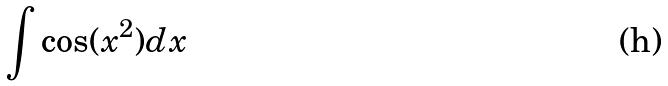<formula> <loc_0><loc_0><loc_500><loc_500>\int \cos ( x ^ { 2 } ) d x</formula> 